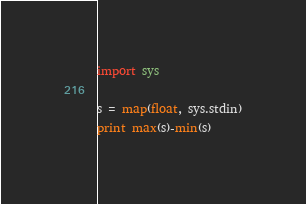<code> <loc_0><loc_0><loc_500><loc_500><_Python_>import sys

s = map(float, sys.stdin)
print max(s)-min(s)</code> 